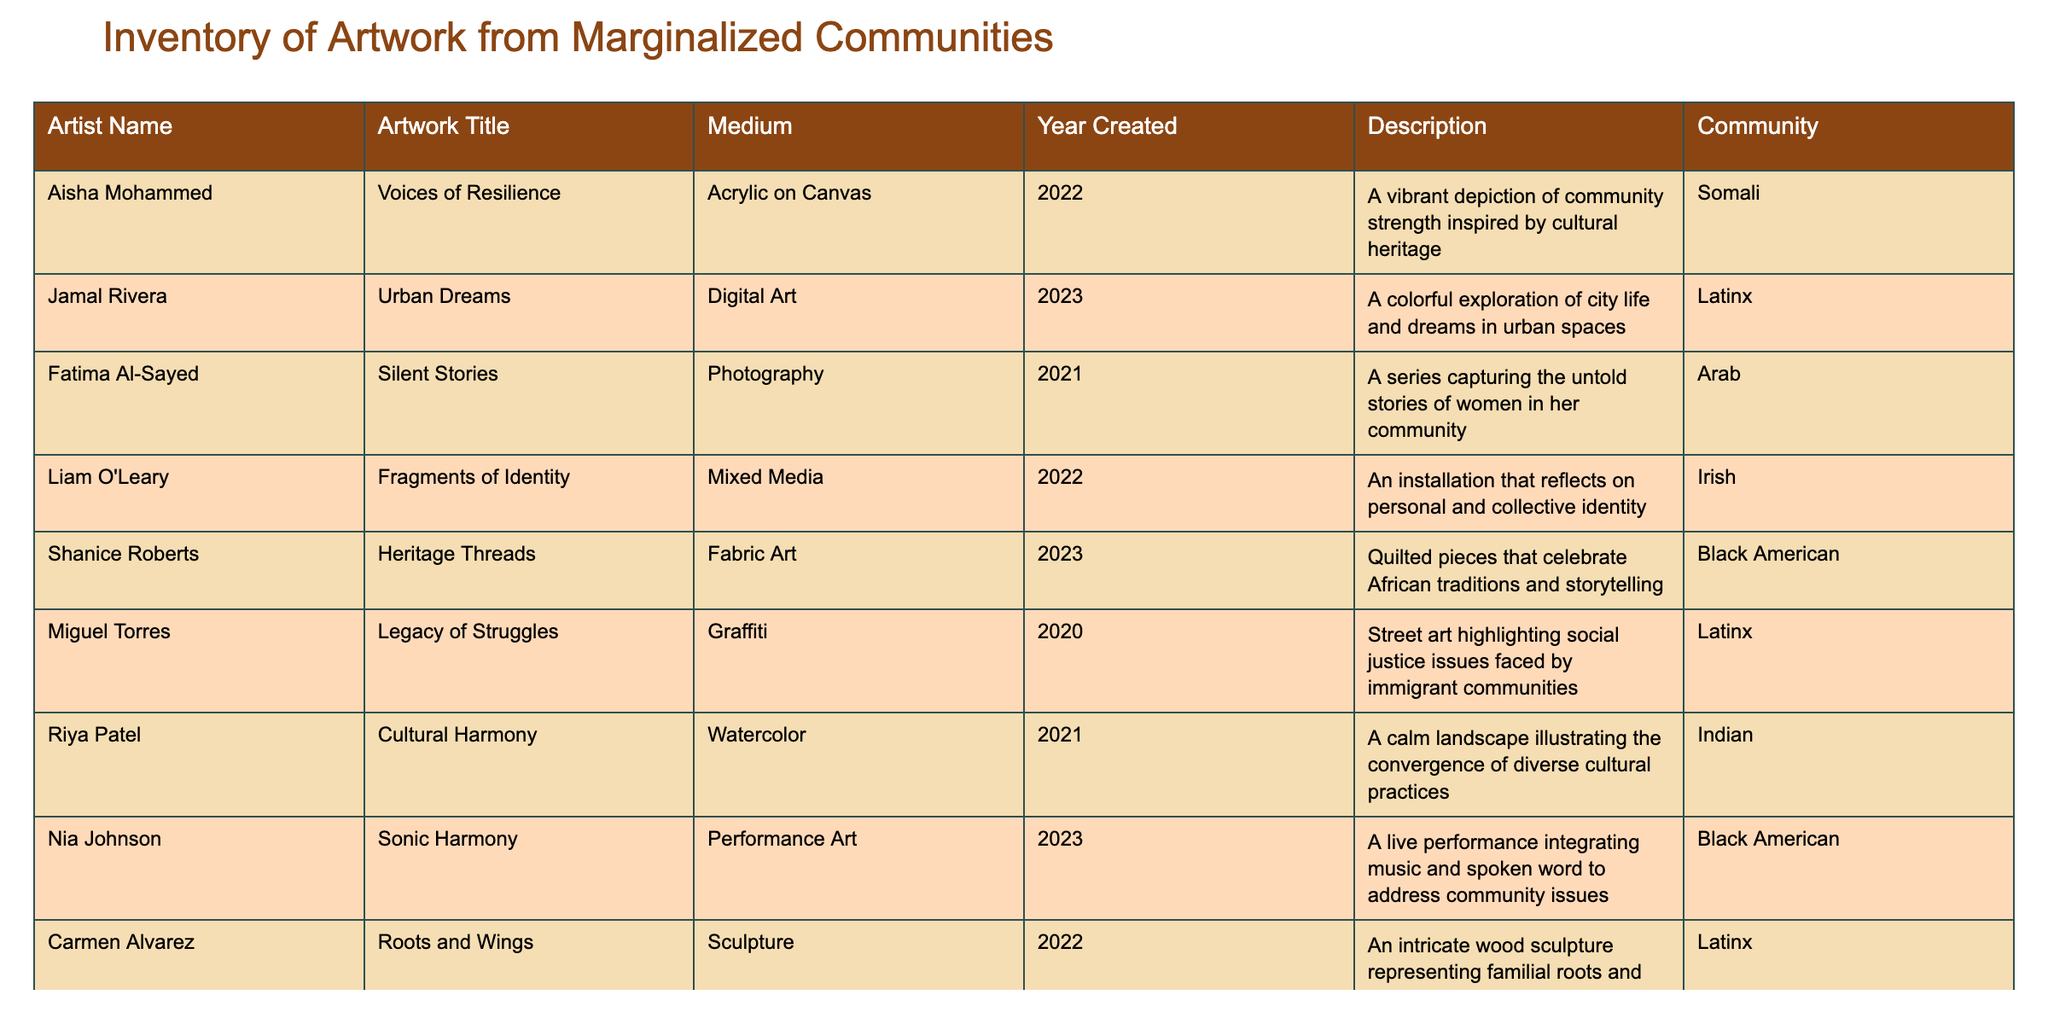What is the title of the artwork created by Aisha Mohammed? The table lists the artist's name in one column and their artwork title in another. By locating Aisha Mohammed in the 'Artist Name' column, we can find her corresponding artwork title in the same row, which is "Voices of Resilience."
Answer: Voices of Resilience How many artworks were created using mixed media? To find the number of artworks created using mixed media, we look for the entries under the 'Medium' column that specify "Mixed Media." There is only one artwork, "Fragments of Identity" by Liam O'Leary, that fits this description.
Answer: 1 Did Fatima Al-Sayed create an artwork in 2022? By reviewing the 'Year Created' column for Fatima Al-Sayed's row, we see her artwork "Silent Stories" was created in 2021. Therefore, the specific year 2022 does not match her artwork.
Answer: No Which community is represented by the artist Nia Johnson? Looking at the 'Community' column while referencing Nia Johnson's row, we can see that she represents the "Black American" community.
Answer: Black American What is the average year of creation for the artworks listed? To find the average, we sum the years of creation: 2022 + 2023 + 2021 + 2022 + 2023 + 2020 + 2021 + 2023 + 2022 + 2023 = 2022. The average is calculated by dividing the sum (2022) by the number of artworks (10), resulting in an average year of 2022.
Answer: 2022 Which artist created the artwork titled "Roots and Wings"? By searching through the 'Artwork Title' column, we find that "Roots and Wings" is associated with Carmen Alvarez.
Answer: Carmen Alvarez How many artworks were created by artists from the Latinx community? We can filter the entries for the 'Community' column that list "Latinx." In total, there are four artworks by Latinx artists: "Urban Dreams," "Legacy of Struggles," "Roots and Wings," and "Carmen Alvarez"; therefore, the answer is four.
Answer: 4 What type of medium did Shanice Roberts use for her artwork? In the table, we reference Shanice Roberts' row and look at the 'Medium' column, finding that she used "Fabric Art" as her medium.
Answer: Fabric Art Is there any artwork listed that focuses on the theme of social justice? By examining the 'Description' column, we can identify if any entries mention social justice. "Legacy of Struggles" by Miguel Torres addresses this theme explicitly, thus the answer is yes.
Answer: Yes 